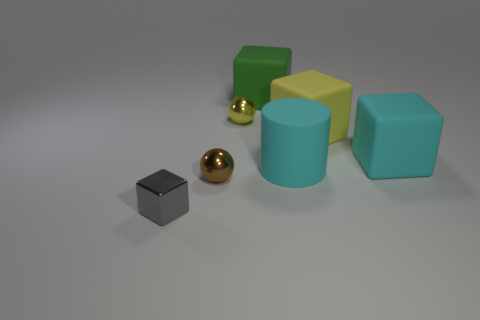If these blocks represented elements in a business environment, what could each color symbolize? If we consider these blocks as metaphors in a business context, one might imagine the yellow block representing energy and optimism, the cyan block reflecting calm communication, the green for financial growth, and the metallic sphere for technological advancement. 